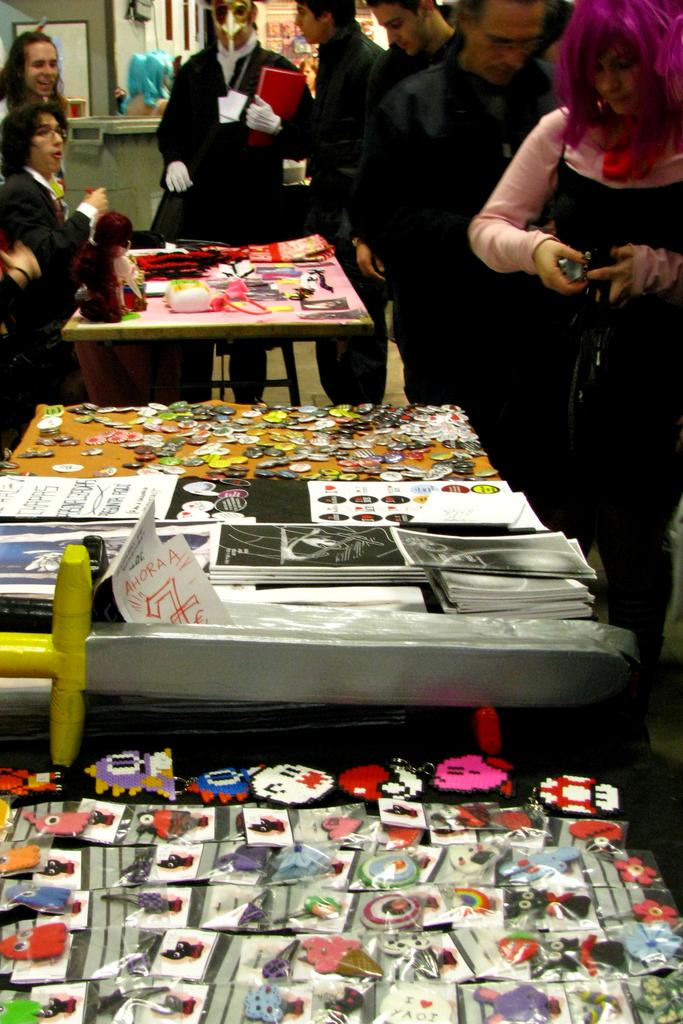Who or what can be seen in the image? There are people in the image. What is the background of the image like? There is a wall in the image. Are there any reflective surfaces in the image? Yes, there is a mirror in the image. What type of furniture is present in the image? There are tables in the image. What items can be found on the tables? There are books, papers, and covers on the tables. What is the army's reaction to the sleet in the image? There is no army or sleet present in the image; it features people, a wall, a mirror, tables, books, papers, and covers. 